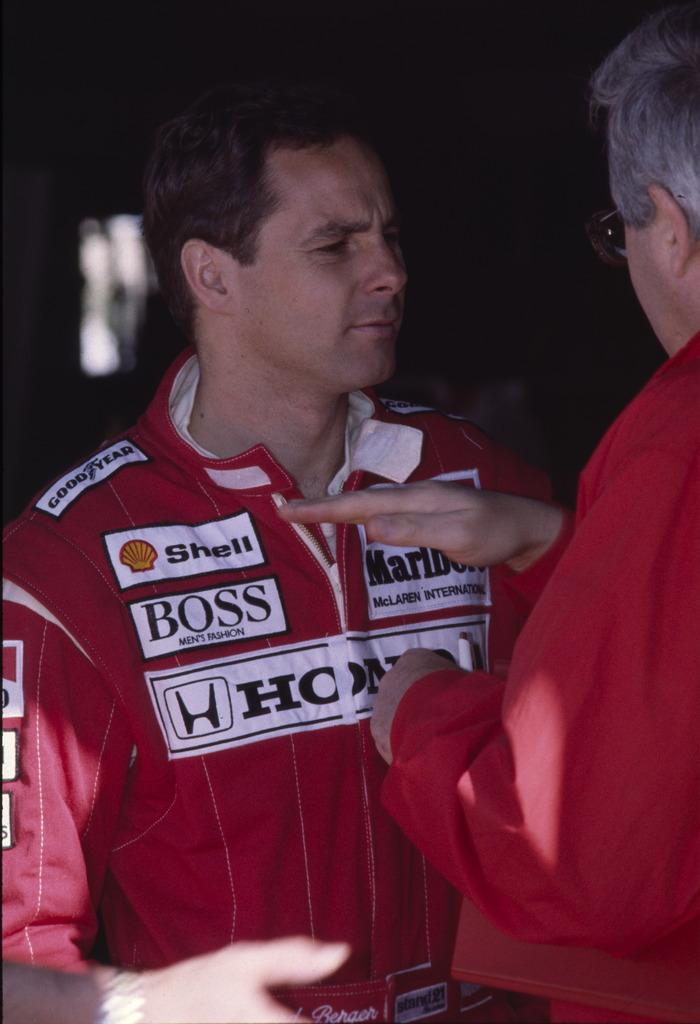Is honda the driver's main sponsor?
Your answer should be compact. Yes. 